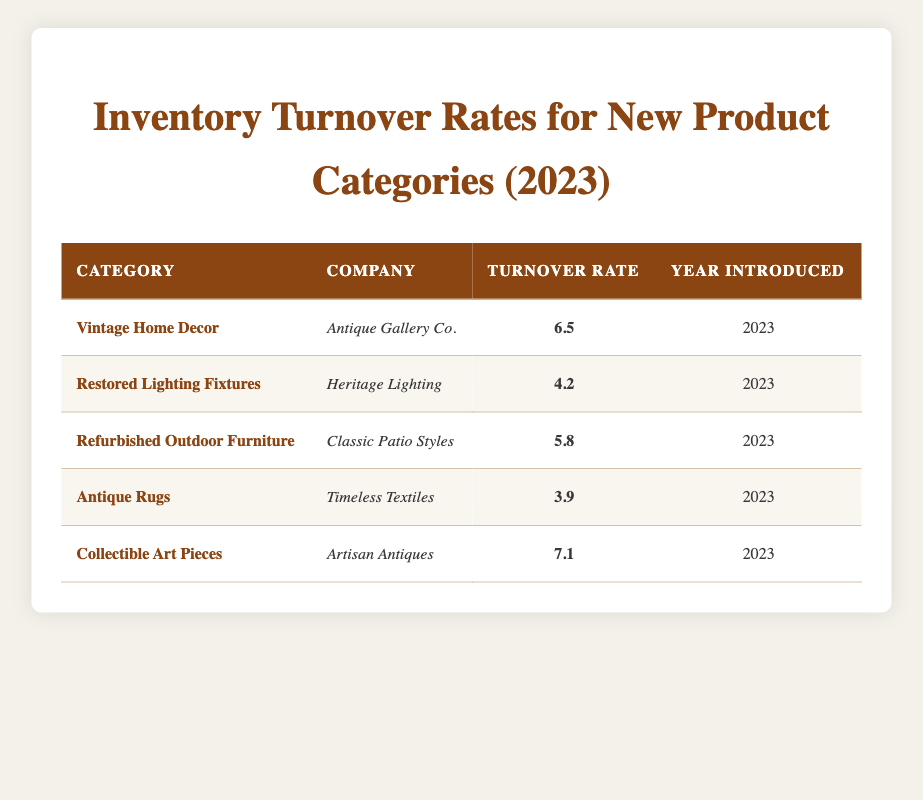What is the highest inventory turnover rate listed in the table? The turnover rates for each product category are 6.5, 4.2, 5.8, 3.9, and 7.1. Comparing these values, the highest turnover rate is 7.1 from the category "Collectible Art Pieces."
Answer: 7.1 Which company introduced the "Restored Lighting Fixtures"? In the table, the category "Restored Lighting Fixtures" is associated with "Heritage Lighting."
Answer: Heritage Lighting What is the average inventory turnover rate for all the categories introduced in 2023? The turnover rates in the table are 6.5, 4.2, 5.8, 3.9, and 7.1. Summing these values gives 27.5. Since there are 5 categories, the average turnover rate is 27.5 divided by 5, which equals 5.5.
Answer: 5.5 Is the turnover rate for "Antique Rugs" higher than 4? The table shows that the turnover rate for "Antique Rugs" is 3.9. Since 3.9 is not higher than 4, the statement is false.
Answer: No Which category has the second lowest inventory turnover rate? The turnover rates from lowest to highest are: Antique Rugs (3.9), Restored Lighting Fixtures (4.2), Refurbished Outdoor Furniture (5.8), Vintage Home Decor (6.5), and Collectible Art Pieces (7.1). Therefore, the second lowest turnover rate is for "Restored Lighting Fixtures" at 4.2.
Answer: Restored Lighting Fixtures 